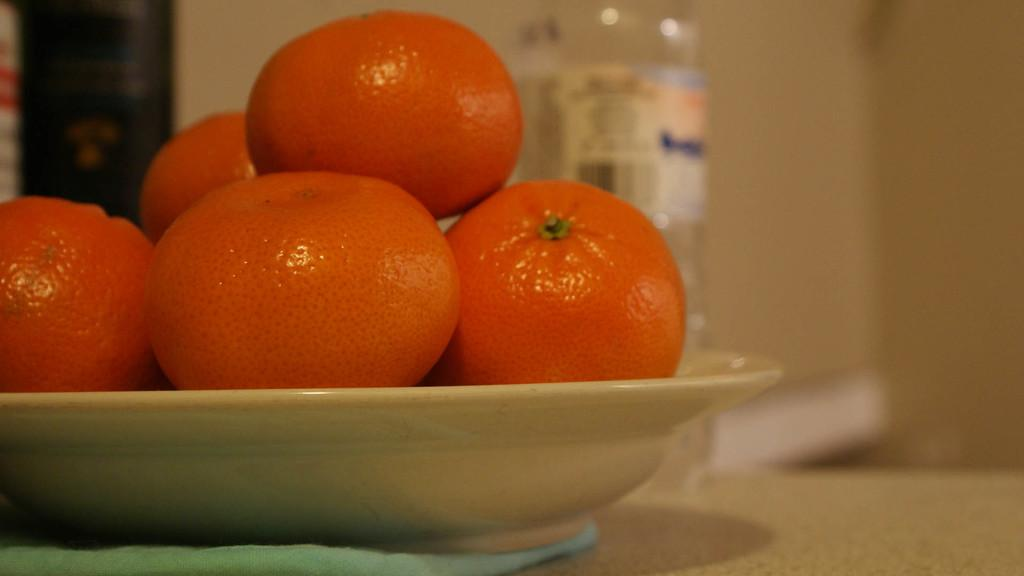What type of fruit is in the plate in the foreground of the image? There are oranges in a plate in the foreground of the image. What is located at the bottom of the image? There is a table at the bottom of the image. What can be seen in the background of the image? There is a bottle and a wall in the background of the image. What type of can is visible in the image? There is no can present in the image. What does the muscle in the image smell like? There is no muscle present in the image, so it cannot be smelled. 